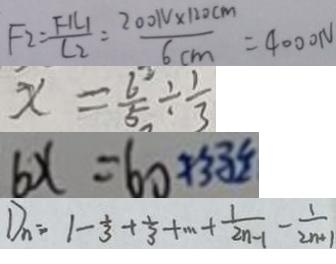Convert formula to latex. <formula><loc_0><loc_0><loc_500><loc_500>F _ { 2 } = \frac { F _ { 1 } L _ { 1 } } { L _ { 2 } } = \frac { 2 0 0 1 v \times 1 2 0 c m } { 6 c m } = 4 0 0 0 1 v 
 x = \frac { 6 } { 5 } \div \frac { 1 } { 3 } 
 b x = b o 
 D _ { n } = 1 - \frac { 1 } { 3 } + \frac { 1 } { 3 } + \cdots + \frac { 1 } { 2 n - 1 } - \frac { 1 } { 2 n + 1 }</formula> 